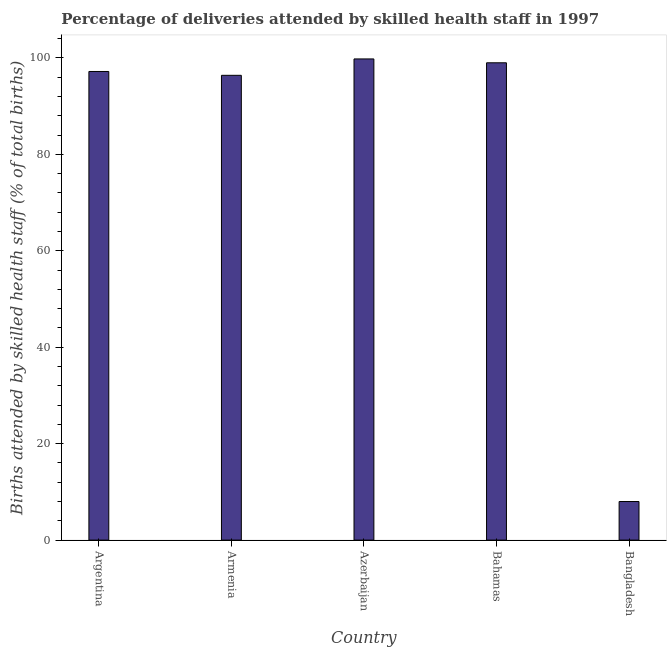What is the title of the graph?
Provide a short and direct response. Percentage of deliveries attended by skilled health staff in 1997. What is the label or title of the Y-axis?
Give a very brief answer. Births attended by skilled health staff (% of total births). Across all countries, what is the maximum number of births attended by skilled health staff?
Provide a short and direct response. 99.8. Across all countries, what is the minimum number of births attended by skilled health staff?
Provide a short and direct response. 8. In which country was the number of births attended by skilled health staff maximum?
Provide a succinct answer. Azerbaijan. What is the sum of the number of births attended by skilled health staff?
Provide a succinct answer. 400.4. What is the difference between the number of births attended by skilled health staff in Armenia and Bangladesh?
Offer a terse response. 88.4. What is the average number of births attended by skilled health staff per country?
Your response must be concise. 80.08. What is the median number of births attended by skilled health staff?
Provide a short and direct response. 97.2. What is the ratio of the number of births attended by skilled health staff in Argentina to that in Bangladesh?
Keep it short and to the point. 12.15. Is the difference between the number of births attended by skilled health staff in Bahamas and Bangladesh greater than the difference between any two countries?
Your answer should be compact. No. Is the sum of the number of births attended by skilled health staff in Argentina and Bangladesh greater than the maximum number of births attended by skilled health staff across all countries?
Your answer should be very brief. Yes. What is the difference between the highest and the lowest number of births attended by skilled health staff?
Ensure brevity in your answer.  91.8. In how many countries, is the number of births attended by skilled health staff greater than the average number of births attended by skilled health staff taken over all countries?
Give a very brief answer. 4. Are all the bars in the graph horizontal?
Your answer should be very brief. No. How many countries are there in the graph?
Make the answer very short. 5. Are the values on the major ticks of Y-axis written in scientific E-notation?
Provide a succinct answer. No. What is the Births attended by skilled health staff (% of total births) in Argentina?
Keep it short and to the point. 97.2. What is the Births attended by skilled health staff (% of total births) of Armenia?
Your answer should be compact. 96.4. What is the Births attended by skilled health staff (% of total births) of Azerbaijan?
Provide a short and direct response. 99.8. What is the difference between the Births attended by skilled health staff (% of total births) in Argentina and Bahamas?
Provide a short and direct response. -1.8. What is the difference between the Births attended by skilled health staff (% of total births) in Argentina and Bangladesh?
Offer a very short reply. 89.2. What is the difference between the Births attended by skilled health staff (% of total births) in Armenia and Bangladesh?
Give a very brief answer. 88.4. What is the difference between the Births attended by skilled health staff (% of total births) in Azerbaijan and Bahamas?
Provide a short and direct response. 0.8. What is the difference between the Births attended by skilled health staff (% of total births) in Azerbaijan and Bangladesh?
Make the answer very short. 91.8. What is the difference between the Births attended by skilled health staff (% of total births) in Bahamas and Bangladesh?
Keep it short and to the point. 91. What is the ratio of the Births attended by skilled health staff (% of total births) in Argentina to that in Armenia?
Offer a terse response. 1.01. What is the ratio of the Births attended by skilled health staff (% of total births) in Argentina to that in Bangladesh?
Offer a very short reply. 12.15. What is the ratio of the Births attended by skilled health staff (% of total births) in Armenia to that in Bahamas?
Give a very brief answer. 0.97. What is the ratio of the Births attended by skilled health staff (% of total births) in Armenia to that in Bangladesh?
Ensure brevity in your answer.  12.05. What is the ratio of the Births attended by skilled health staff (% of total births) in Azerbaijan to that in Bahamas?
Give a very brief answer. 1.01. What is the ratio of the Births attended by skilled health staff (% of total births) in Azerbaijan to that in Bangladesh?
Your response must be concise. 12.47. What is the ratio of the Births attended by skilled health staff (% of total births) in Bahamas to that in Bangladesh?
Ensure brevity in your answer.  12.38. 